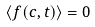<formula> <loc_0><loc_0><loc_500><loc_500>\langle f ( c , t ) \rangle = 0</formula> 